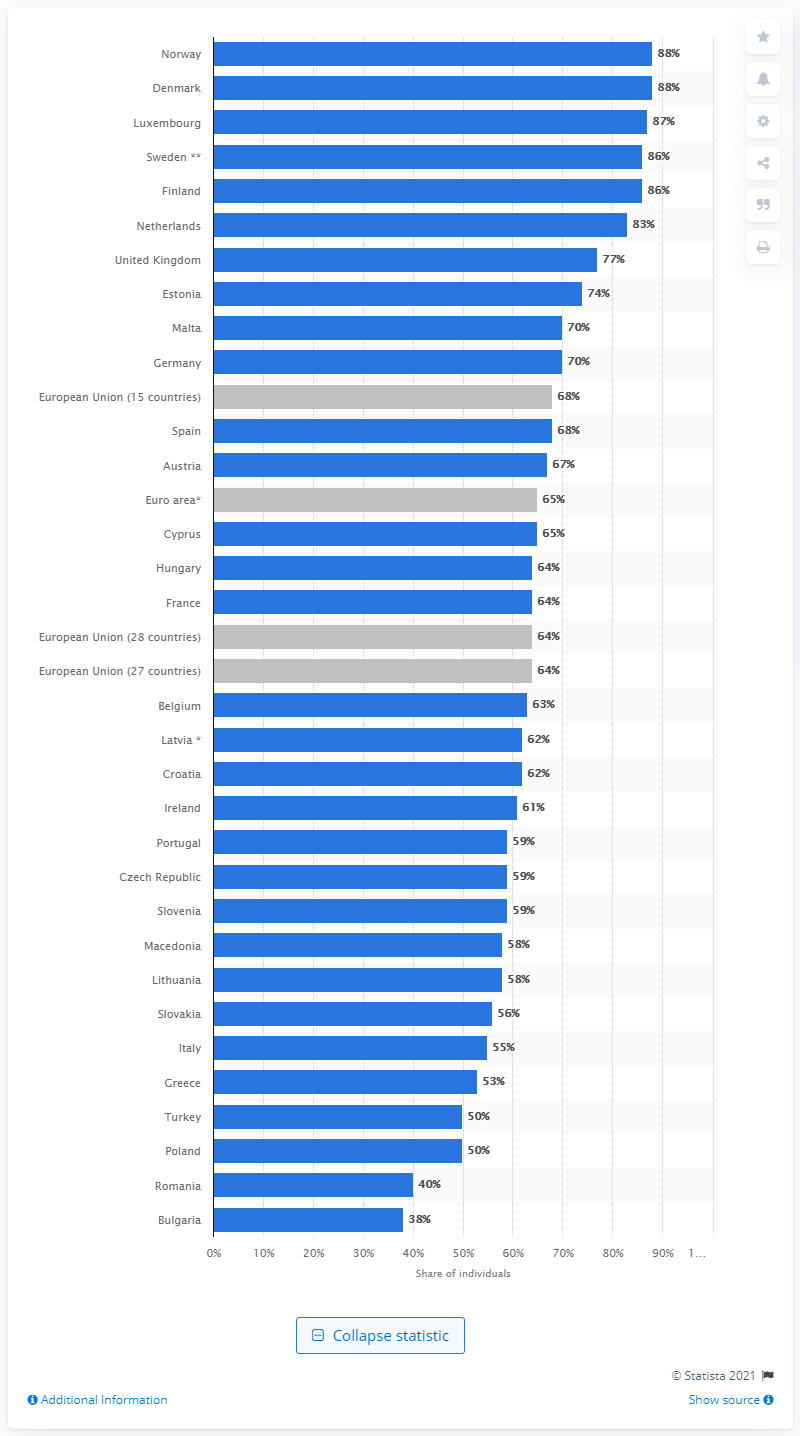Identify some key points in this picture. In 2016, Norway had the highest level of online media consumption among all countries. 